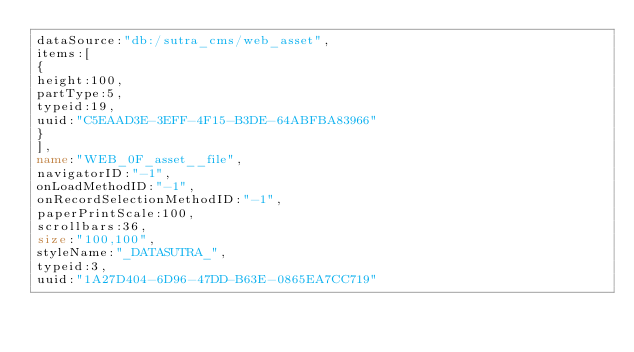<code> <loc_0><loc_0><loc_500><loc_500><_VisualBasic_>dataSource:"db:/sutra_cms/web_asset",
items:[
{
height:100,
partType:5,
typeid:19,
uuid:"C5EAAD3E-3EFF-4F15-B3DE-64ABFBA83966"
}
],
name:"WEB_0F_asset__file",
navigatorID:"-1",
onLoadMethodID:"-1",
onRecordSelectionMethodID:"-1",
paperPrintScale:100,
scrollbars:36,
size:"100,100",
styleName:"_DATASUTRA_",
typeid:3,
uuid:"1A27D404-6D96-47DD-B63E-0865EA7CC719"</code> 